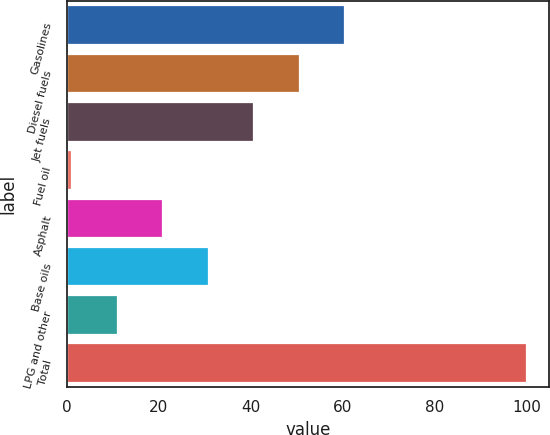Convert chart. <chart><loc_0><loc_0><loc_500><loc_500><bar_chart><fcel>Gasolines<fcel>Diesel fuels<fcel>Jet fuels<fcel>Fuel oil<fcel>Asphalt<fcel>Base oils<fcel>LPG and other<fcel>Total<nl><fcel>60.4<fcel>50.5<fcel>40.6<fcel>1<fcel>20.8<fcel>30.7<fcel>10.9<fcel>100<nl></chart> 